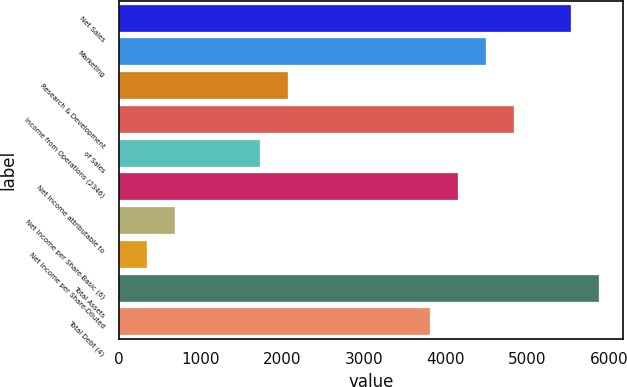Convert chart to OTSL. <chart><loc_0><loc_0><loc_500><loc_500><bar_chart><fcel>Net Sales<fcel>Marketing<fcel>Research & Development<fcel>Income from Operations (2346)<fcel>of Sales<fcel>Net Income attributable to<fcel>Net Income per Share-Basic (6)<fcel>Net Income per Share-Diluted<fcel>Total Assets<fcel>Total Debt (4)<nl><fcel>5530.76<fcel>4493.87<fcel>2074.46<fcel>4839.5<fcel>1728.83<fcel>4148.24<fcel>691.94<fcel>346.31<fcel>5876.39<fcel>3802.61<nl></chart> 